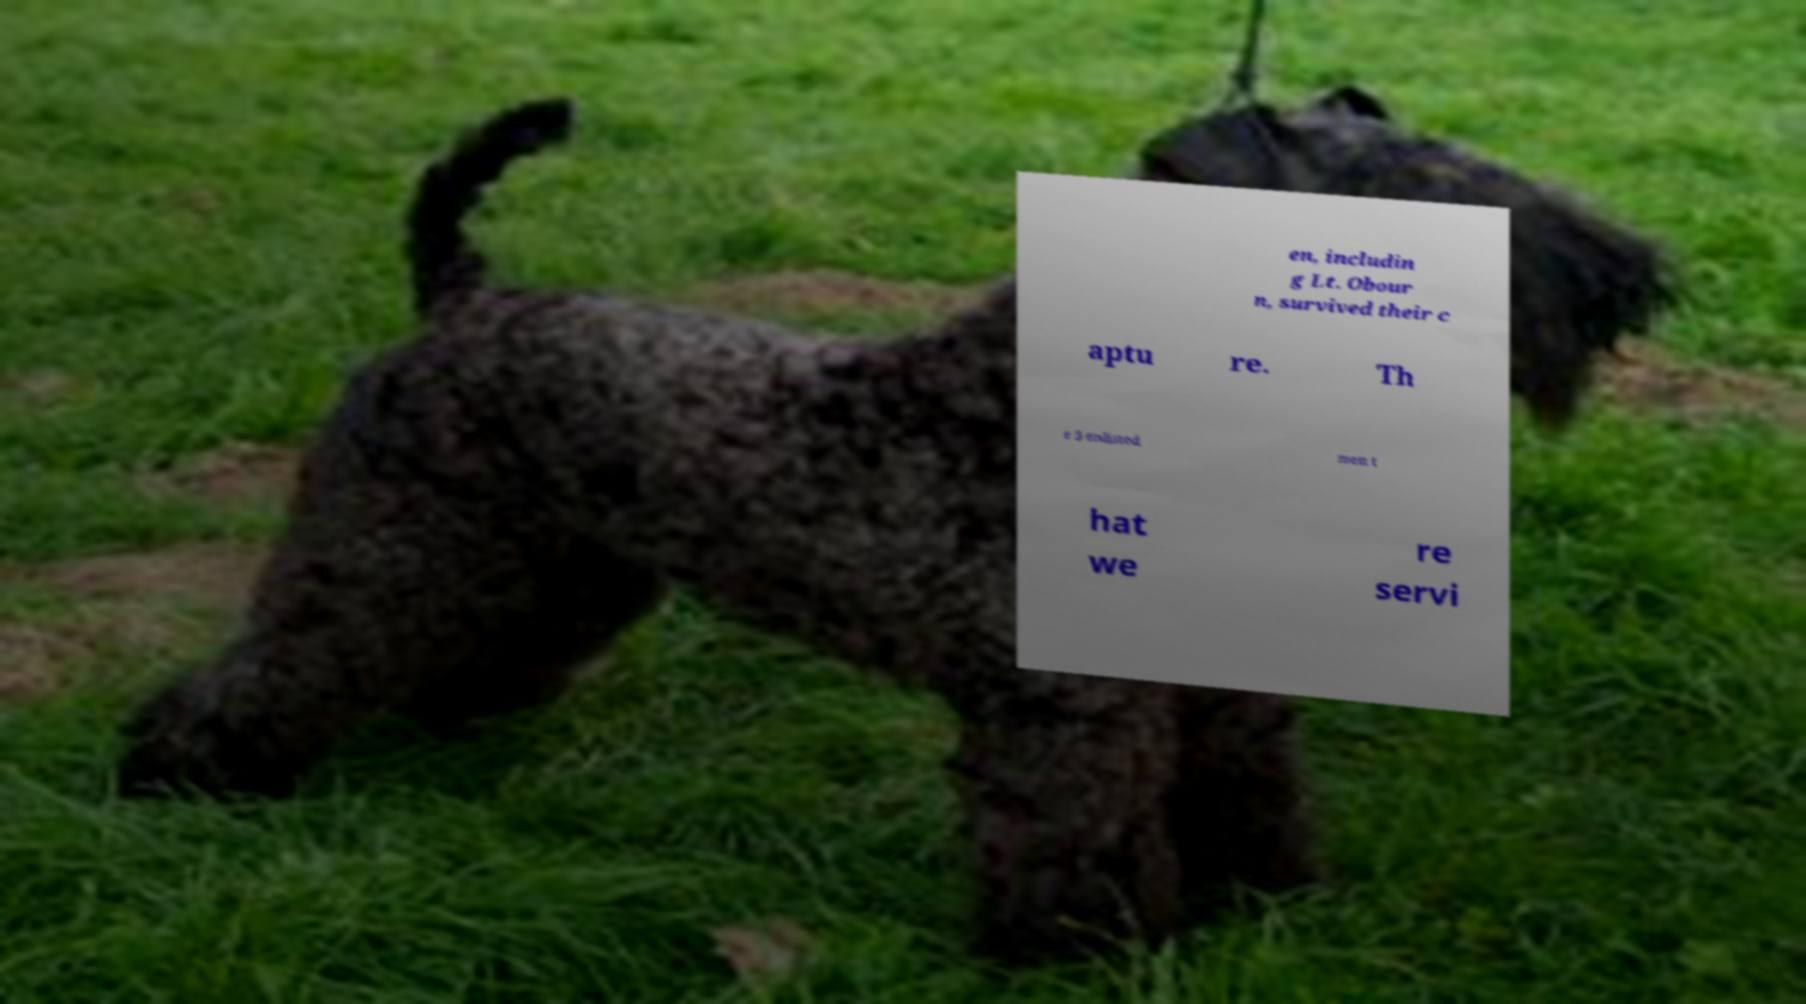Can you read and provide the text displayed in the image?This photo seems to have some interesting text. Can you extract and type it out for me? en, includin g Lt. Obour n, survived their c aptu re. Th e 5 enlisted men t hat we re servi 